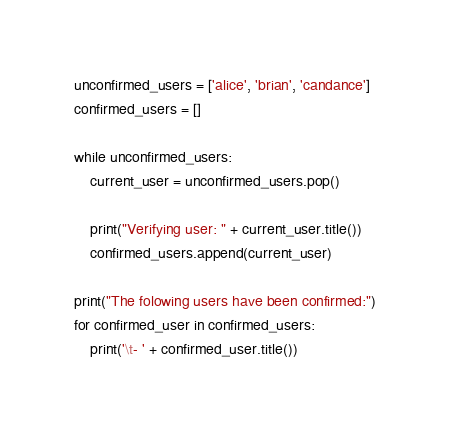Convert code to text. <code><loc_0><loc_0><loc_500><loc_500><_Python_>unconfirmed_users = ['alice', 'brian', 'candance']
confirmed_users = []

while unconfirmed_users:
    current_user = unconfirmed_users.pop()

    print("Verifying user: " + current_user.title())
    confirmed_users.append(current_user)

print("The folowing users have been confirmed:")
for confirmed_user in confirmed_users:
    print('\t- ' + confirmed_user.title())
</code> 